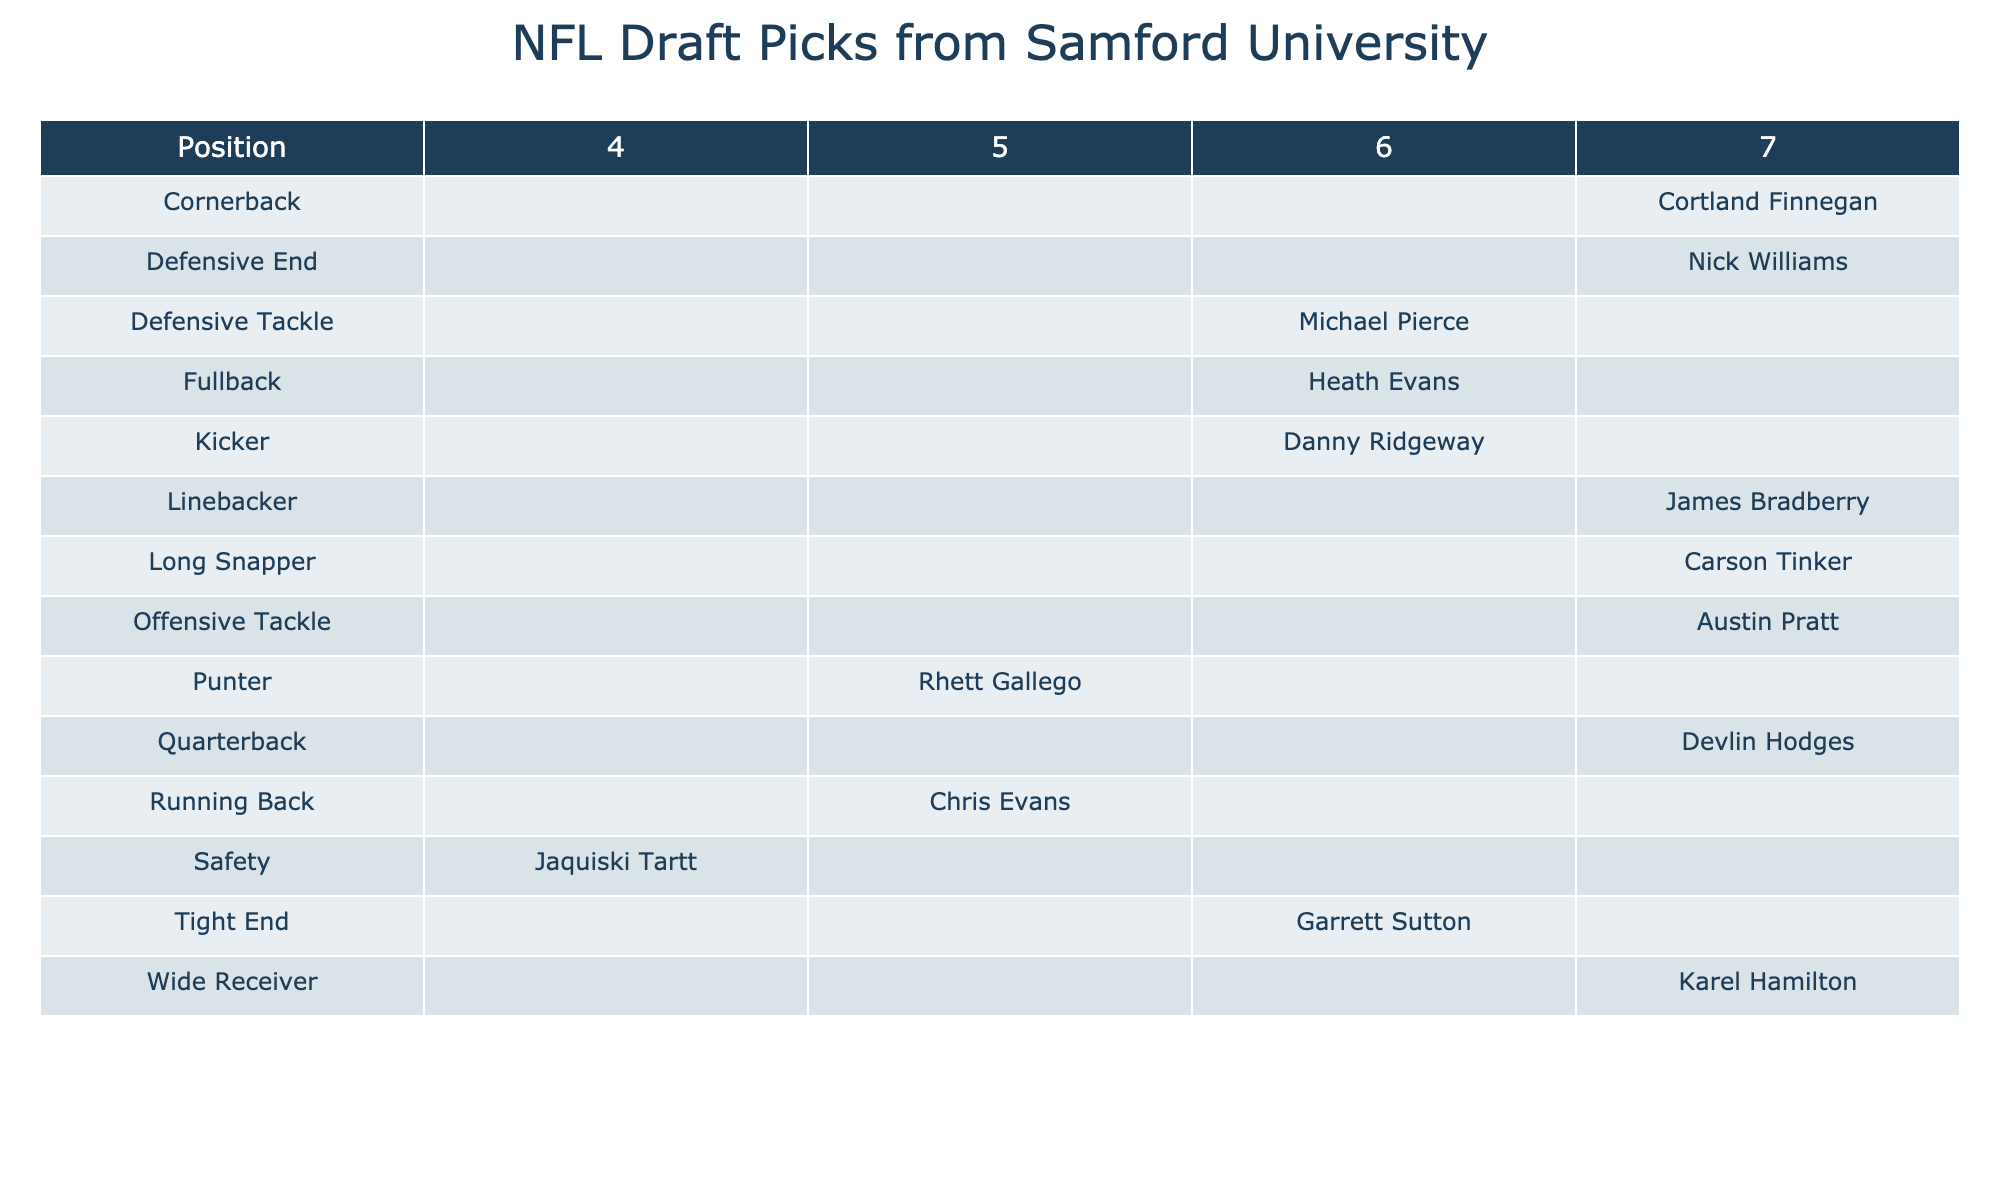What position has the most draft picks? By examining the 'Position' column in the table, we can see that several positions have draft picks; however, counting the number of players listed, 'Cornerback' is represented by only one player while 'Defensive End' has one player too. However, looking closely, 'Wide Receiver,' 'Long Snapper,' and 'Quarterback' also have only one representative, but as you move through each position, it shows that many drafts have players with one each. Thus, technically no singular position has the highest count, and it is evenly distributed among several.
Answer: None holds the majority Which round had the most draft picks? By reviewing the 'Round' column and counting the occurrences of each round, it captures the frequency of players drafted. The 7th round has five players, which is more than any other round.
Answer: 7th round Who was drafted as a quarterback and in which round? By scanning the table for the 'Quarterback' position, we find Devlin Hodges listed alongside the 7th round.
Answer: Devlin Hodges, 7th round Did Samford University produce a kicker in the NFL draft? Referring to the table, we look in the 'Position' column for 'Kicker,' where we find Danny Ridgeway drafted in the 6th round. This confirms that they did.
Answer: Yes How many different positions were drafted in the 6th round? Inspecting the 6th round's player listings, we count the distinct positions: 'Defensive Tackle,' 'Tight End,' 'Kicker,' and 'Fullback'; thus, there are four unique positions represented.
Answer: 4 Which team selected the player Jaquiski Tartt? In the 'Player' row, we locate Jaquiski Tartt, which shows that he was drafted by the San Francisco 49ers according to the 'Team' column in the entry.
Answer: San Francisco 49ers Is there any player drafted in a round lower than 5 who is a defensive player? Examining the rounds for defensive players, we identify Cortland Finnegan (7th round) and Nick Williams (7th round), confirming that both are drafted in a round lower than 5.
Answer: Yes What is the total number of players drafted in positions other than running back? By identifying running backs listed (Chris Evans), we find there are 10 players in total. Excluding Evans gives us 9 other positions.
Answer: 9 Compare the number of tight ends and fullbacks drafted. How do they compare? Checking the counts in the respective 'Position' categories, we find one tight end (Garrett Sutton) and one fullback (Heath Evans). Hence, they are equal regarding the number of players drafted in each position.
Answer: Equal Which player drafted in 2013 was a defensive end? Referring to the 'Year' column, we find Nick Williams drafted in 2013 listed under the 'Defensive End' position.
Answer: Nick Williams 